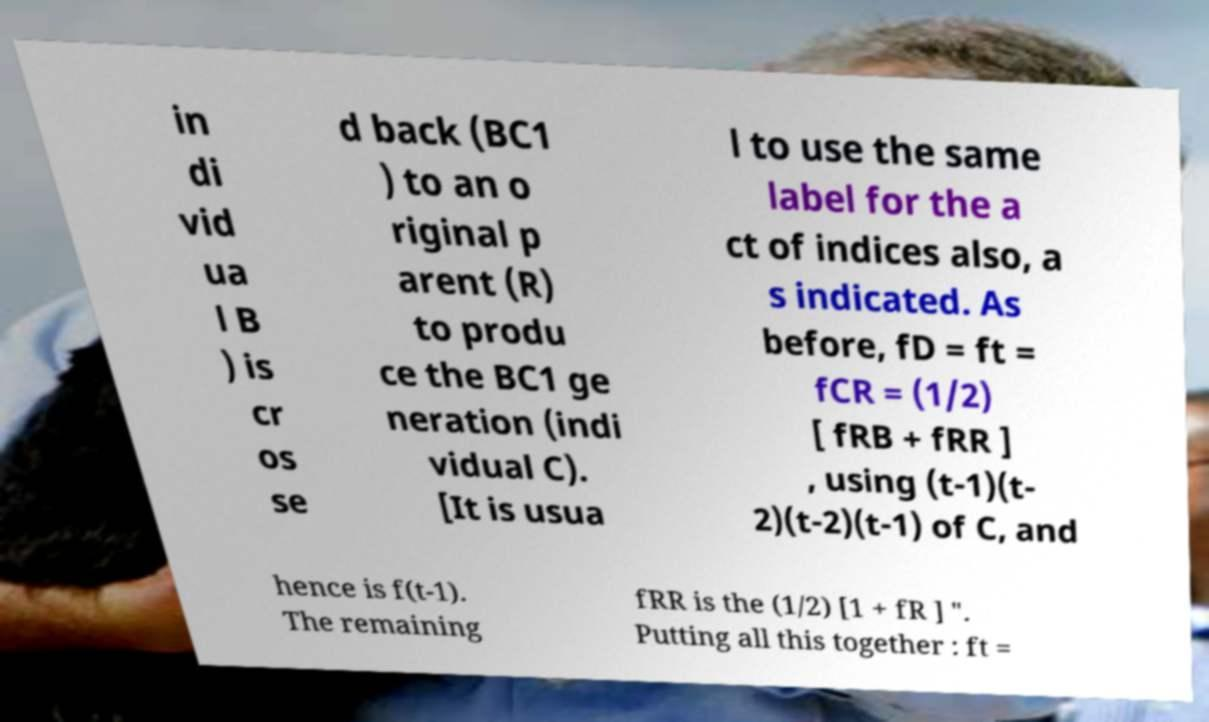Can you read and provide the text displayed in the image?This photo seems to have some interesting text. Can you extract and type it out for me? in di vid ua l B ) is cr os se d back (BC1 ) to an o riginal p arent (R) to produ ce the BC1 ge neration (indi vidual C). [It is usua l to use the same label for the a ct of indices also, a s indicated. As before, fD = ft = fCR = (1/2) [ fRB + fRR ] , using (t-1)(t- 2)(t-2)(t-1) of C, and hence is f(t-1). The remaining fRR is the (1/2) [1 + fR ] ". Putting all this together : ft = 